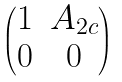Convert formula to latex. <formula><loc_0><loc_0><loc_500><loc_500>\begin{pmatrix} 1 & A _ { 2 c } \\ 0 & 0 \end{pmatrix}</formula> 